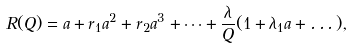Convert formula to latex. <formula><loc_0><loc_0><loc_500><loc_500>R ( Q ) = a + r _ { 1 } a ^ { 2 } + r _ { 2 } a ^ { 3 } + \dots + \frac { \lambda } { Q } ( 1 + \lambda _ { 1 } a + \dots ) ,</formula> 